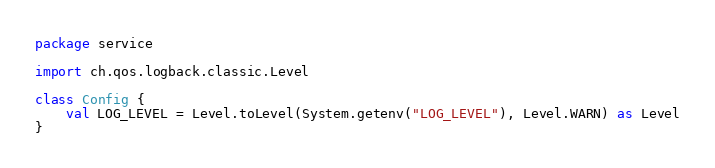Convert code to text. <code><loc_0><loc_0><loc_500><loc_500><_Kotlin_>package service

import ch.qos.logback.classic.Level

class Config {
    val LOG_LEVEL = Level.toLevel(System.getenv("LOG_LEVEL"), Level.WARN) as Level
}</code> 